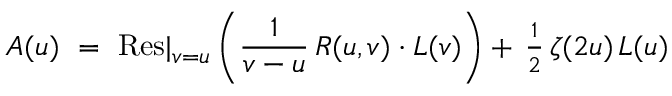<formula> <loc_0><loc_0><loc_500><loc_500>A ( u ) = R e s | _ { v = u } \left ( { \frac { 1 } { v - u } } \, R ( u , v ) \cdot L ( v ) \right ) + \, { \frac { 1 } { 2 } } \, \zeta ( 2 u ) \, L ( u )</formula> 